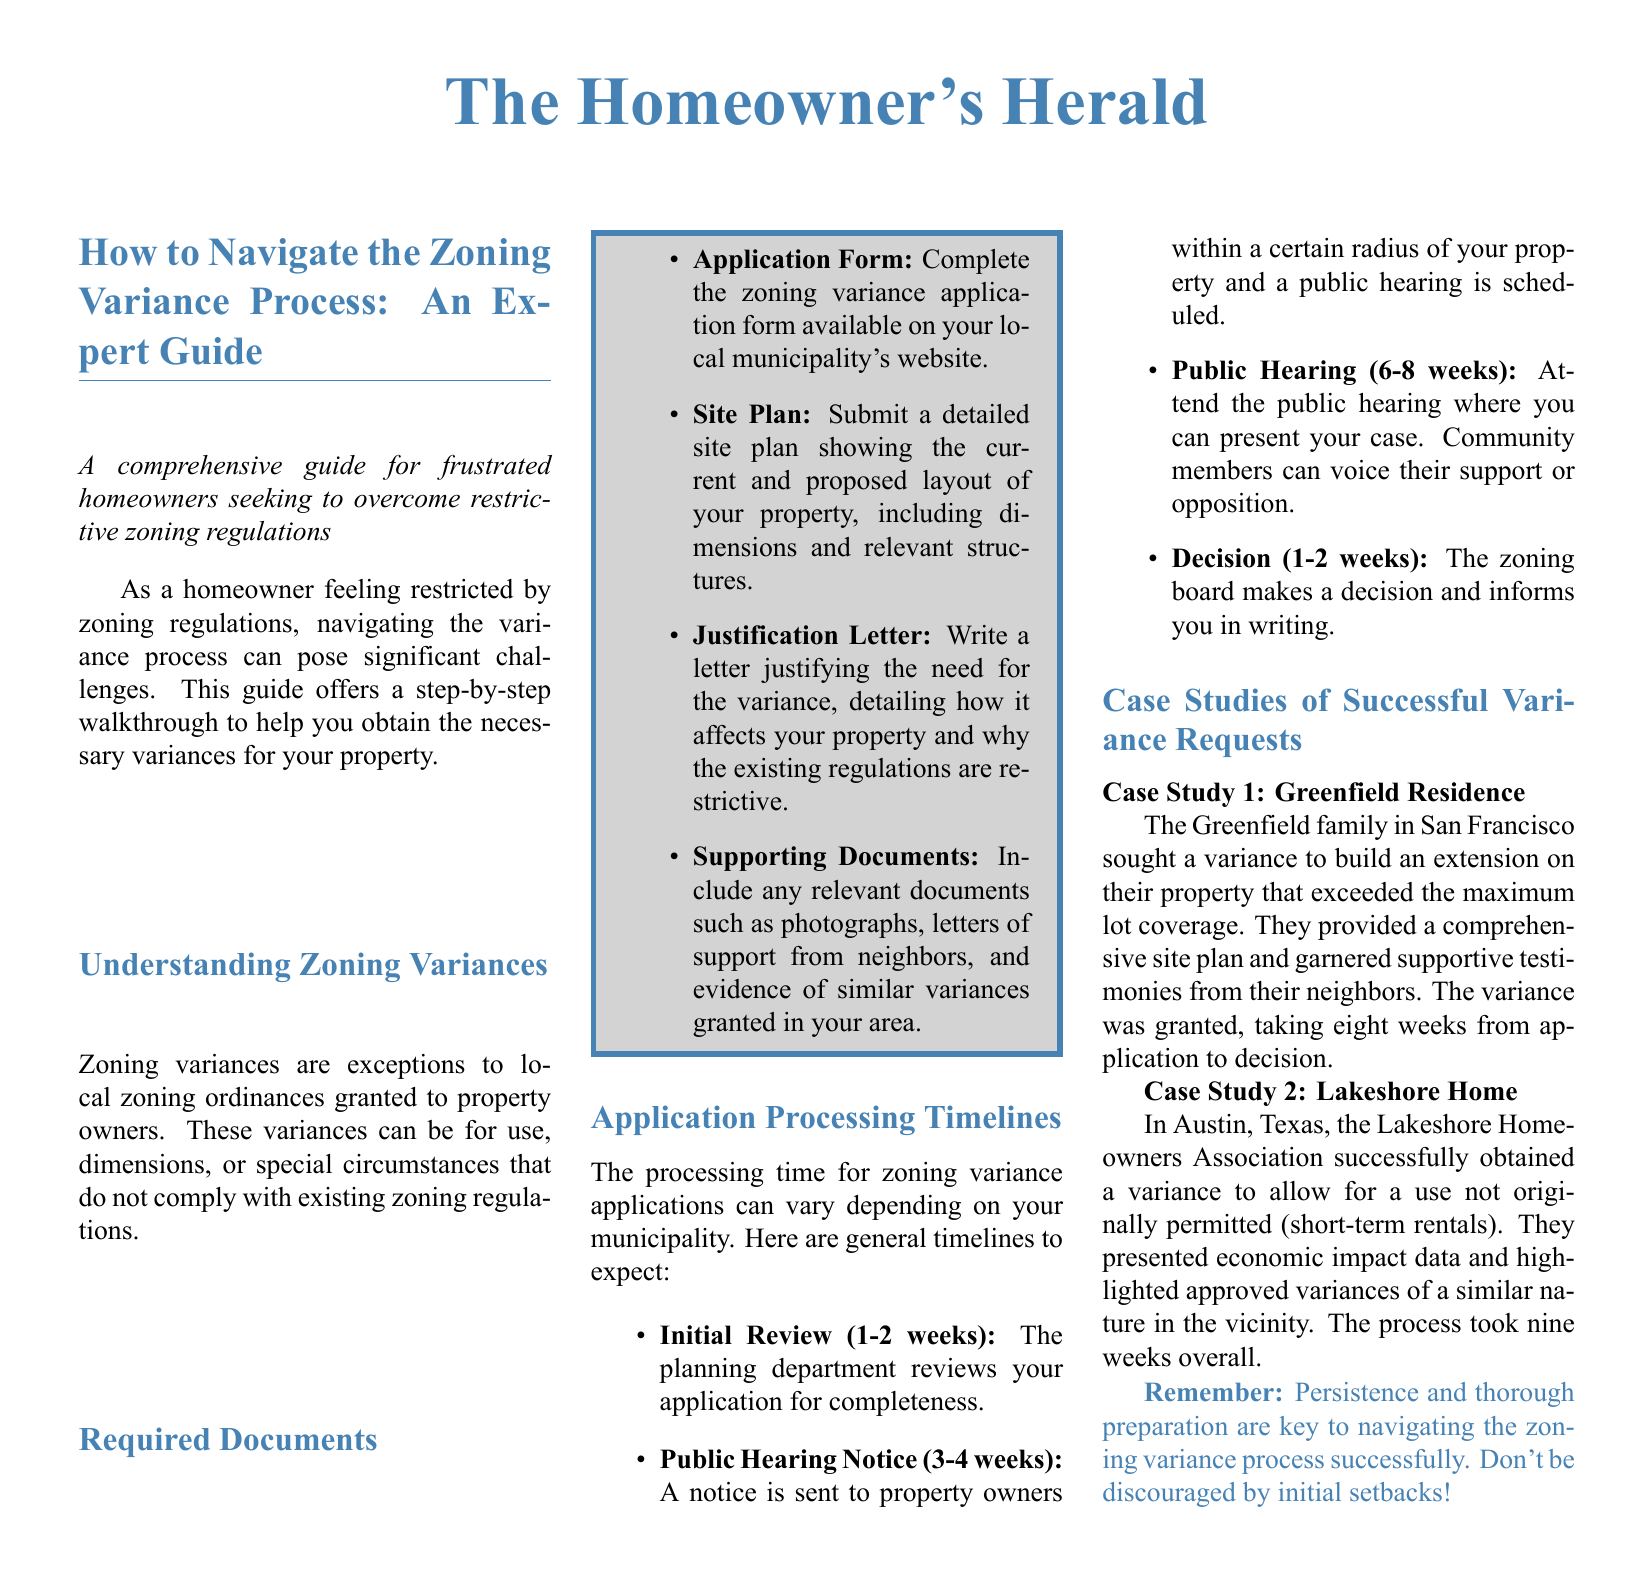What is a zoning variance? A zoning variance is an exception to local zoning ordinances granted to property owners.
Answer: Exception to local zoning ordinances What is the first step to apply for a variance? The first step is to complete the zoning variance application form available on your local municipality's website.
Answer: Complete the application form How long does the initial review take? The initial review of the variance application typically takes 1-2 weeks.
Answer: 1-2 weeks Which document supports the justification for a variance? The document that supports the justification for a variance is the Justification Letter.
Answer: Justification Letter How many case studies are provided in the document? The document provides two case studies of successful variance requests.
Answer: Two What type of feedback can community members provide during the public hearing? Community members can voice their support or opposition during the public hearing.
Answer: Support or opposition What is highlighted as key to navigating the variance process? Persistence and thorough preparation are highlighted as key to navigating the variance process.
Answer: Persistence and thorough preparation What type of zoning variance was granted to the Greenfield family? The Greenfield family received a variance to build an extension that exceeded the maximum lot coverage.
Answer: Extension exceeding maximum lot coverage What is the overall timeline for the Lakeshore Home variance process? The overall timeline for the Lakeshore Home variance process took nine weeks.
Answer: Nine weeks 